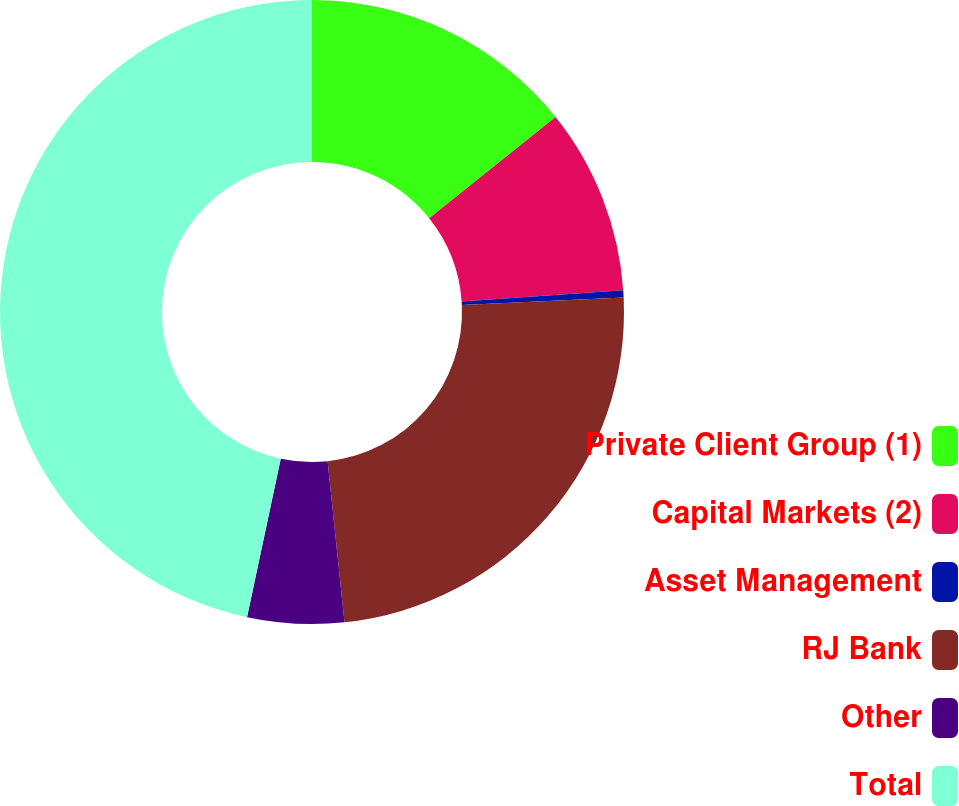Convert chart to OTSL. <chart><loc_0><loc_0><loc_500><loc_500><pie_chart><fcel>Private Client Group (1)<fcel>Capital Markets (2)<fcel>Asset Management<fcel>RJ Bank<fcel>Other<fcel>Total<nl><fcel>14.26%<fcel>9.63%<fcel>0.37%<fcel>24.08%<fcel>5.0%<fcel>46.66%<nl></chart> 